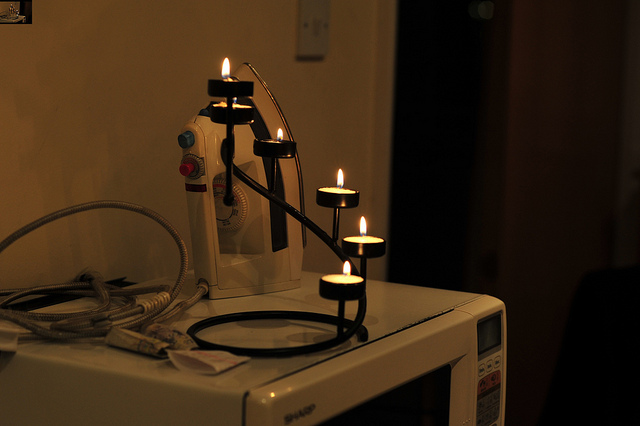<image>What are the holder sculpted to look like? I don't know what the holder is sculpted to look like. It can be seen as candles, stairs, cups or a staircase. What are the holder sculpted to look like? I don't know what the holder is sculpted to look like. It can be candles, stairs, cups, or other things. 